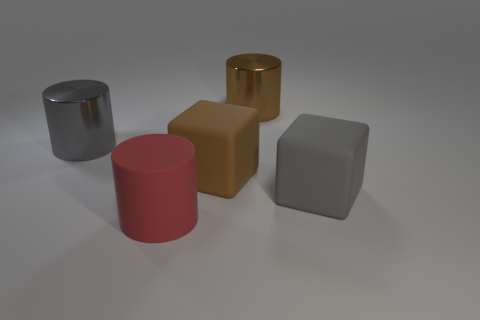Is the number of brown blocks in front of the red cylinder less than the number of gray rubber cubes? After closely examining the image, there appears to be one brown block and two different cubes, one silver and the other gray. The number of brown blocks is indeed less than the number of gray rubber cubes since there is only one brown block and a single gray cube in the image. 